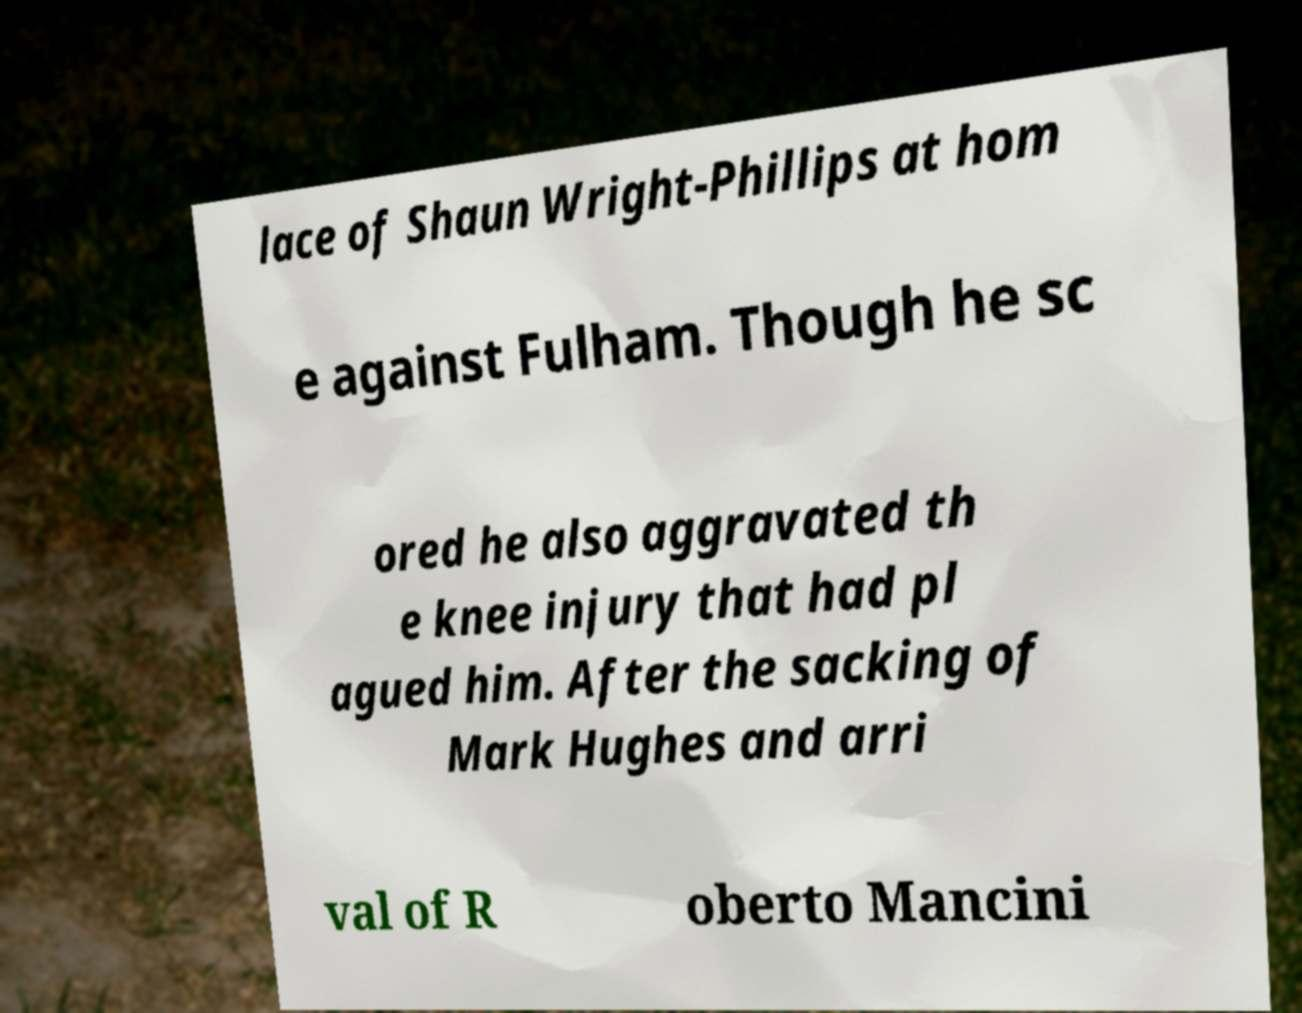Please read and relay the text visible in this image. What does it say? lace of Shaun Wright-Phillips at hom e against Fulham. Though he sc ored he also aggravated th e knee injury that had pl agued him. After the sacking of Mark Hughes and arri val of R oberto Mancini 